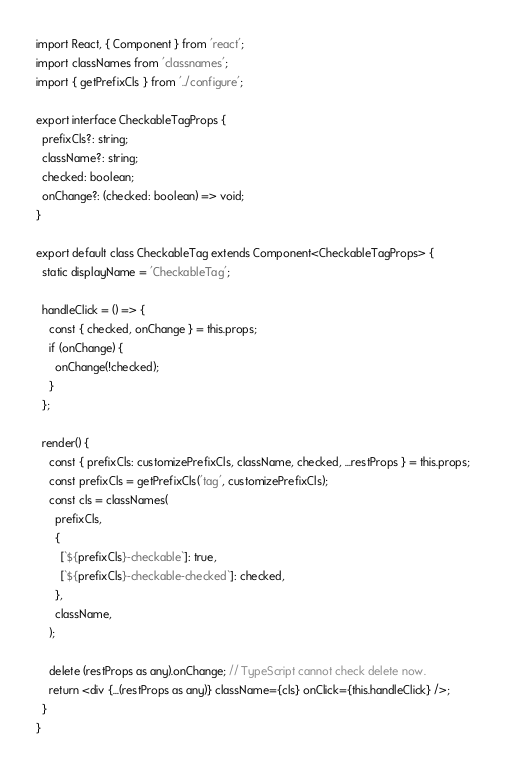<code> <loc_0><loc_0><loc_500><loc_500><_TypeScript_>import React, { Component } from 'react';
import classNames from 'classnames';
import { getPrefixCls } from '../configure';

export interface CheckableTagProps {
  prefixCls?: string;
  className?: string;
  checked: boolean;
  onChange?: (checked: boolean) => void;
}

export default class CheckableTag extends Component<CheckableTagProps> {
  static displayName = 'CheckableTag';

  handleClick = () => {
    const { checked, onChange } = this.props;
    if (onChange) {
      onChange(!checked);
    }
  };

  render() {
    const { prefixCls: customizePrefixCls, className, checked, ...restProps } = this.props;
    const prefixCls = getPrefixCls('tag', customizePrefixCls);
    const cls = classNames(
      prefixCls,
      {
        [`${prefixCls}-checkable`]: true,
        [`${prefixCls}-checkable-checked`]: checked,
      },
      className,
    );

    delete (restProps as any).onChange; // TypeScript cannot check delete now.
    return <div {...(restProps as any)} className={cls} onClick={this.handleClick} />;
  }
}
</code> 